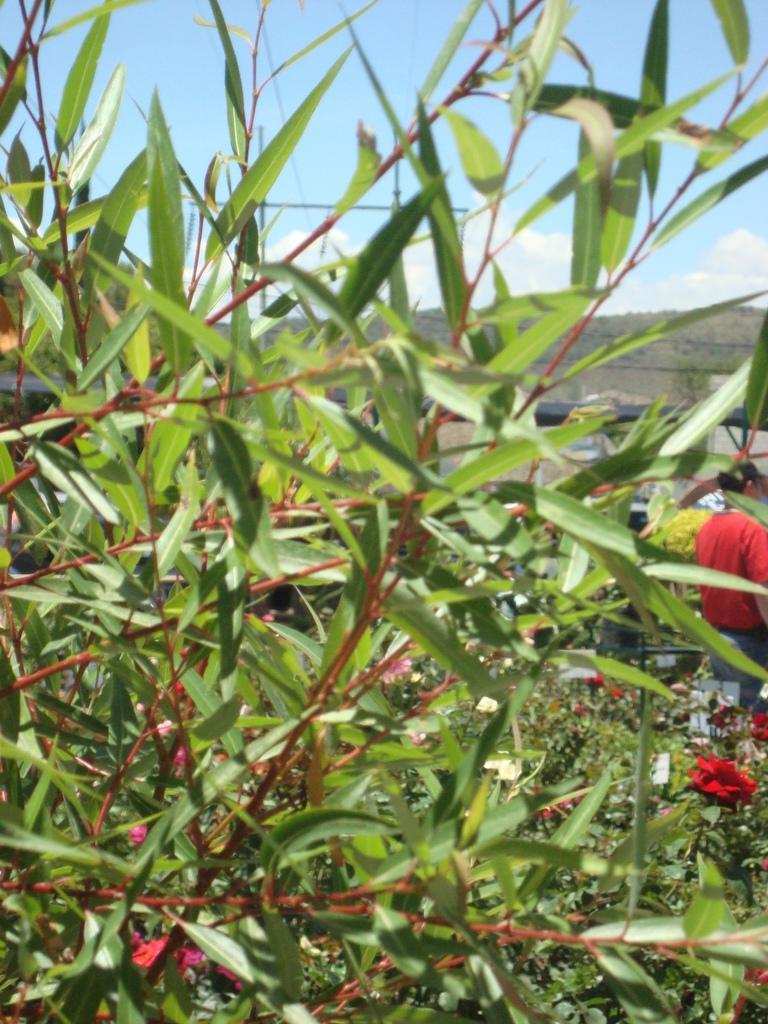Could you give a brief overview of what you see in this image? In this image we can see a group of plants with flowers. On the backside we can see a person standing, the hills and the sky which looks cloudy. 